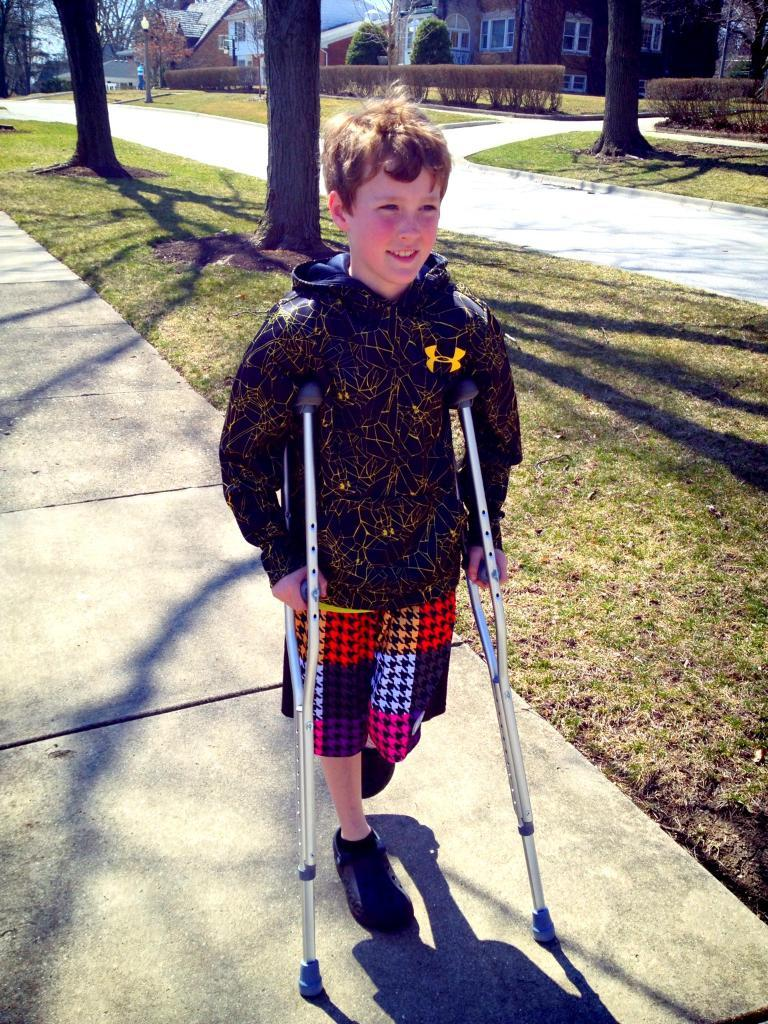What is the main subject of the image? The main subject of the image is a handicap boy. What is the boy doing in the image? The boy is standing with sticks and giving a pose to the camera. How does the boy appear in the image? The boy is smiling in the image. What can be seen in the background of the image? There are tree trunks and shed houses visible in the background. What type of fruit is being served at the feast in the image? There is no feast or fruit present in the image; it features a handicap boy standing with sticks and giving a pose to the camera. What branch is the boy holding in the image? The boy is holding sticks, not branches, in the image. 